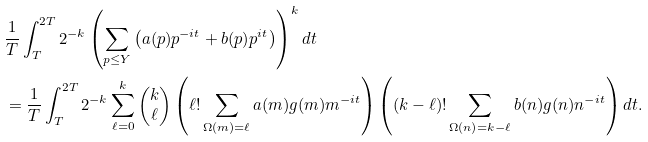<formula> <loc_0><loc_0><loc_500><loc_500>& \frac { 1 } { T } \int _ { T } ^ { 2 T } 2 ^ { - k } \left ( \sum _ { p \leq Y } \left ( a ( p ) p ^ { - i t } + b ( p ) p ^ { i t } \right ) \right ) ^ { k } d t \\ & = \frac { 1 } { T } \int _ { T } ^ { 2 T } 2 ^ { - k } \sum _ { \ell = 0 } ^ { k } \begin{pmatrix} k \\ \ell \end{pmatrix} \left ( \ell ! \sum _ { \Omega ( m ) = \ell } a ( m ) g ( m ) m ^ { - i t } \right ) \left ( ( k - \ell ) ! \sum _ { \Omega ( n ) = k - \ell } b ( n ) g ( n ) n ^ { - i t } \right ) d t .</formula> 